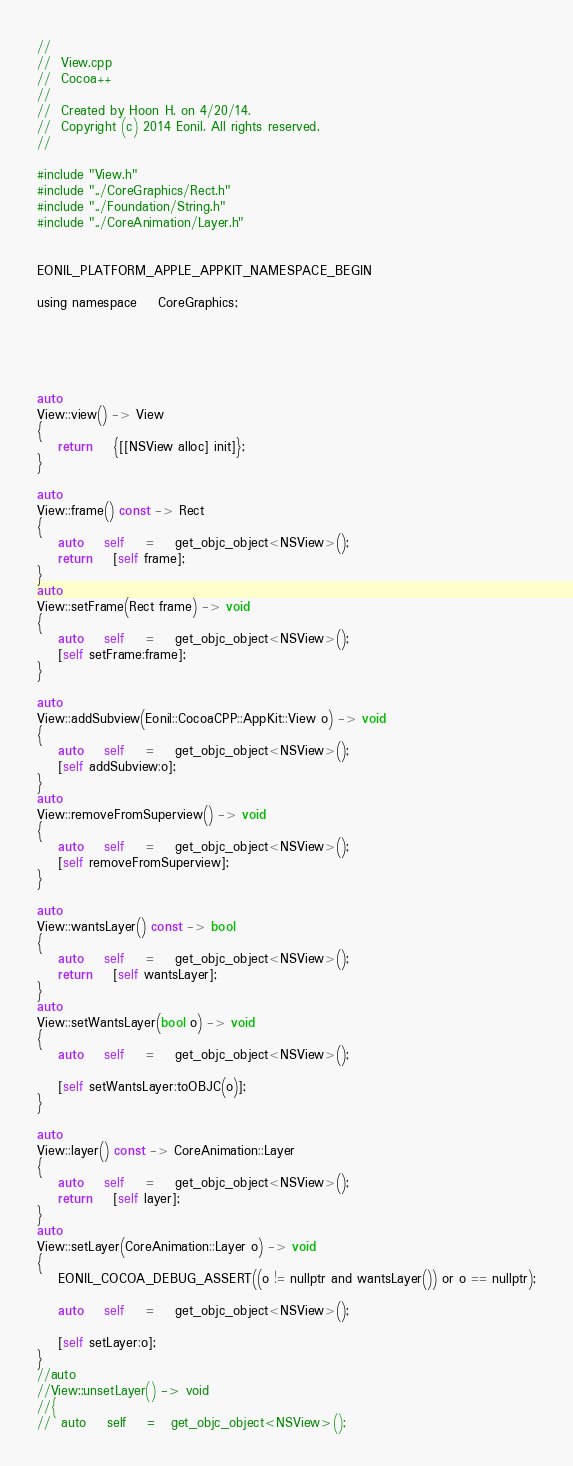<code> <loc_0><loc_0><loc_500><loc_500><_ObjectiveC_>//
//  View.cpp
//  Cocoa++
//
//  Created by Hoon H. on 4/20/14.
//  Copyright (c) 2014 Eonil. All rights reserved.
//

#include "View.h"
#include "../CoreGraphics/Rect.h"
#include "../Foundation/String.h"
#include "../CoreAnimation/Layer.h"


EONIL_PLATFORM_APPLE_APPKIT_NAMESPACE_BEGIN

using namespace	CoreGraphics;





auto
View::view() -> View
{
	return	{[[NSView alloc] init]};
}

auto
View::frame() const -> Rect
{
	auto	self	=	get_objc_object<NSView>();
	return	[self frame];
}
auto
View::setFrame(Rect frame) -> void
{
	auto	self	=	get_objc_object<NSView>();
	[self setFrame:frame];
}

auto
View::addSubview(Eonil::CocoaCPP::AppKit::View o) -> void
{
	auto	self	=	get_objc_object<NSView>();
	[self addSubview:o];
}
auto
View::removeFromSuperview() -> void
{
	auto	self	=	get_objc_object<NSView>();
	[self removeFromSuperview];
}

auto
View::wantsLayer() const -> bool
{
	auto	self	=	get_objc_object<NSView>();
	return	[self wantsLayer];
}
auto
View::setWantsLayer(bool o) -> void
{
	auto	self	=	get_objc_object<NSView>();
	
	[self setWantsLayer:toOBJC(o)];
}

auto
View::layer() const -> CoreAnimation::Layer
{
	auto	self	=	get_objc_object<NSView>();
	return	[self layer];
}
auto
View::setLayer(CoreAnimation::Layer o) -> void
{
	EONIL_COCOA_DEBUG_ASSERT((o != nullptr and wantsLayer()) or o == nullptr);
	
	auto	self	=	get_objc_object<NSView>();
	
	[self setLayer:o];
}
//auto
//View::unsetLayer() -> void
//{
//	auto	self	=	get_objc_object<NSView>();</code> 